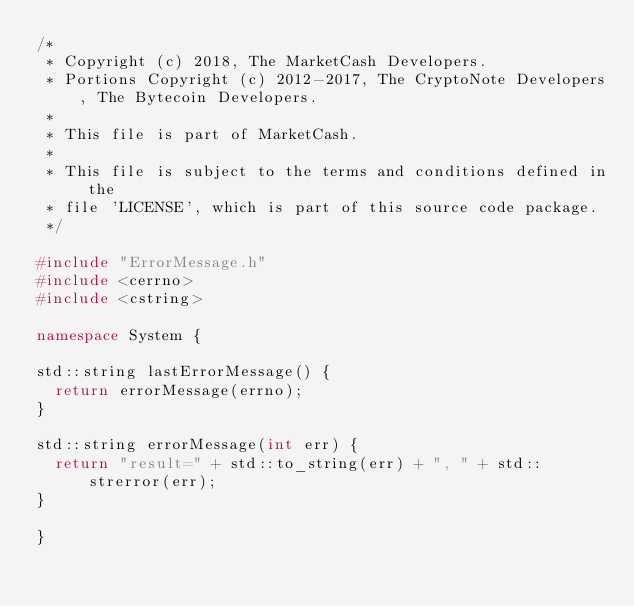Convert code to text. <code><loc_0><loc_0><loc_500><loc_500><_C++_>/*
 * Copyright (c) 2018, The MarketCash Developers.
 * Portions Copyright (c) 2012-2017, The CryptoNote Developers, The Bytecoin Developers.
 *
 * This file is part of MarketCash.
 *
 * This file is subject to the terms and conditions defined in the
 * file 'LICENSE', which is part of this source code package.
 */

#include "ErrorMessage.h"
#include <cerrno>
#include <cstring>

namespace System {

std::string lastErrorMessage() {
  return errorMessage(errno);
}

std::string errorMessage(int err) {
  return "result=" + std::to_string(err) + ", " + std::strerror(err);
}

}
</code> 